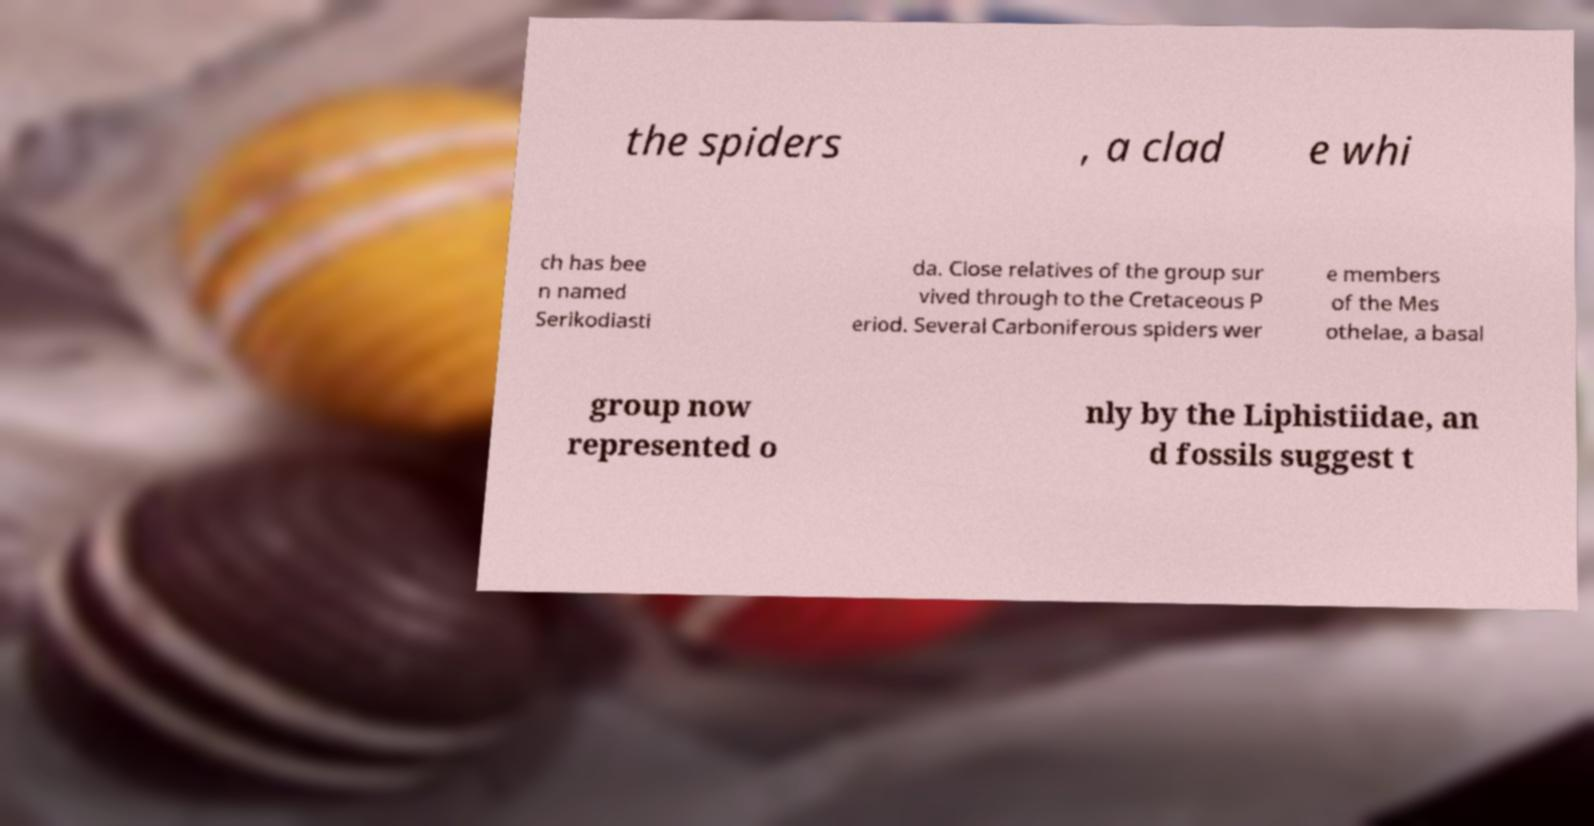There's text embedded in this image that I need extracted. Can you transcribe it verbatim? the spiders , a clad e whi ch has bee n named Serikodiasti da. Close relatives of the group sur vived through to the Cretaceous P eriod. Several Carboniferous spiders wer e members of the Mes othelae, a basal group now represented o nly by the Liphistiidae, an d fossils suggest t 